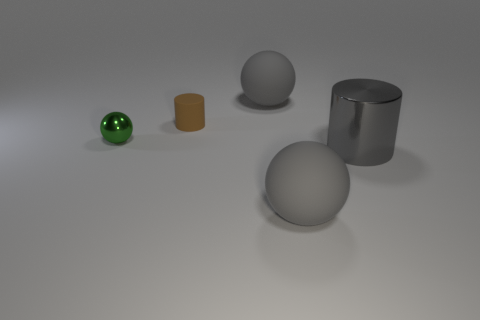What number of other things are there of the same color as the matte cylinder?
Your answer should be very brief. 0. There is a object that is behind the gray cylinder and in front of the brown matte cylinder; what color is it?
Provide a succinct answer. Green. There is a gray thing to the right of the gray matte thing that is in front of the tiny thing that is on the left side of the tiny matte thing; what is its size?
Provide a short and direct response. Large. What number of things are tiny green balls behind the big gray metallic cylinder or gray cylinders right of the metallic ball?
Your answer should be very brief. 2. What is the shape of the brown thing?
Keep it short and to the point. Cylinder. How many other things are there of the same material as the tiny brown cylinder?
Your answer should be very brief. 2. There is a gray thing that is the same shape as the small brown object; what is its size?
Ensure brevity in your answer.  Large. The cylinder that is on the right side of the gray matte sphere to the left of the rubber ball that is in front of the small brown matte cylinder is made of what material?
Offer a very short reply. Metal. Are there any gray things?
Your answer should be compact. Yes. Does the tiny shiny ball have the same color as the large thing that is behind the small rubber thing?
Offer a very short reply. No. 